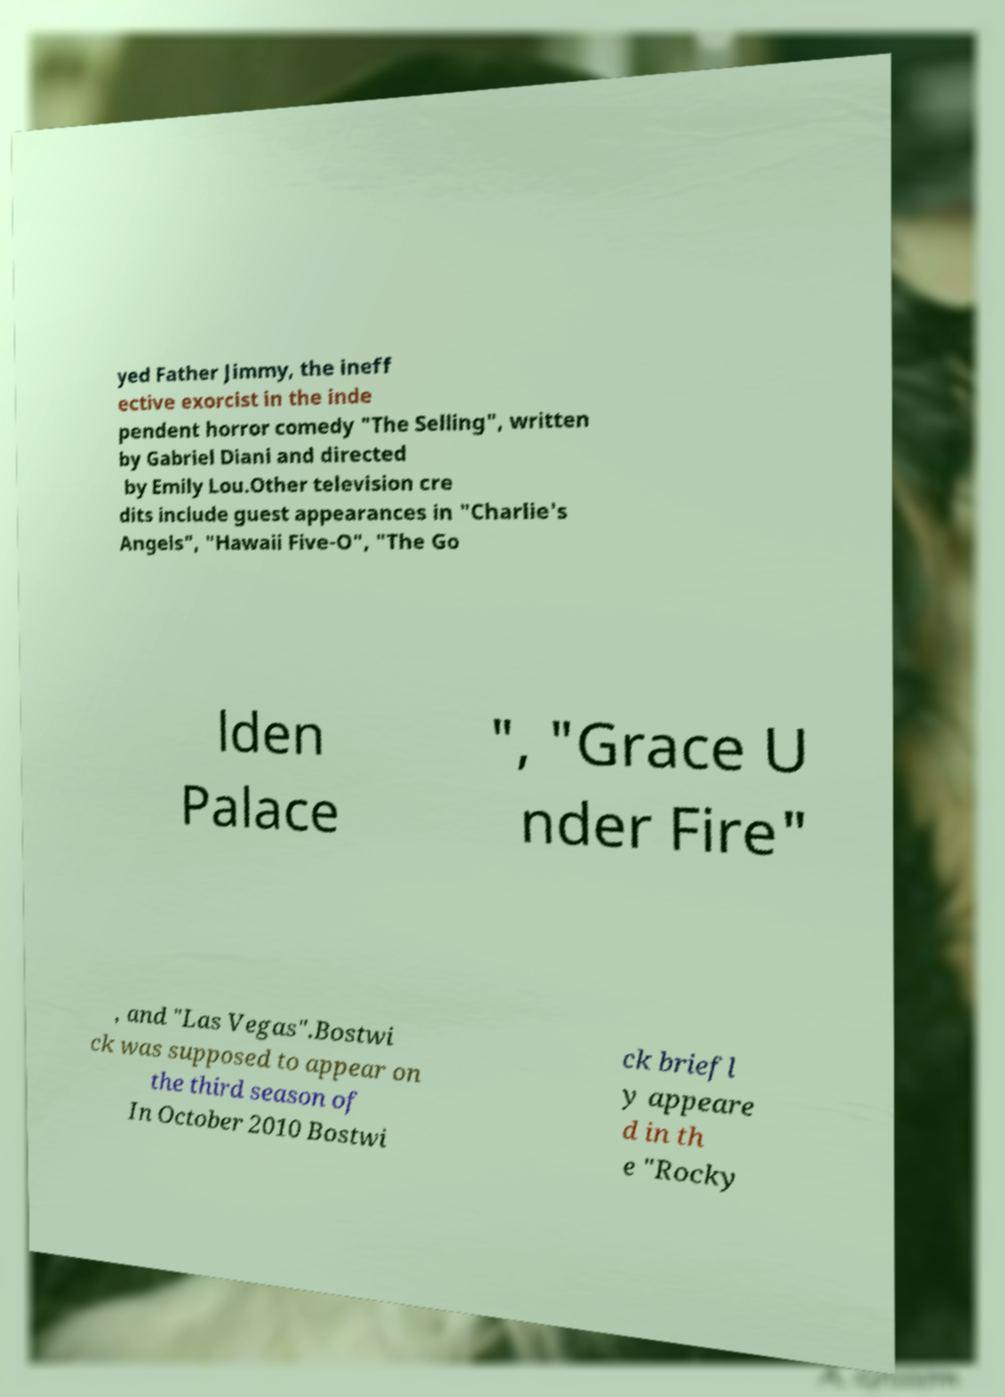Could you assist in decoding the text presented in this image and type it out clearly? yed Father Jimmy, the ineff ective exorcist in the inde pendent horror comedy "The Selling", written by Gabriel Diani and directed by Emily Lou.Other television cre dits include guest appearances in "Charlie's Angels", "Hawaii Five-O", "The Go lden Palace ", "Grace U nder Fire" , and "Las Vegas".Bostwi ck was supposed to appear on the third season of In October 2010 Bostwi ck briefl y appeare d in th e "Rocky 